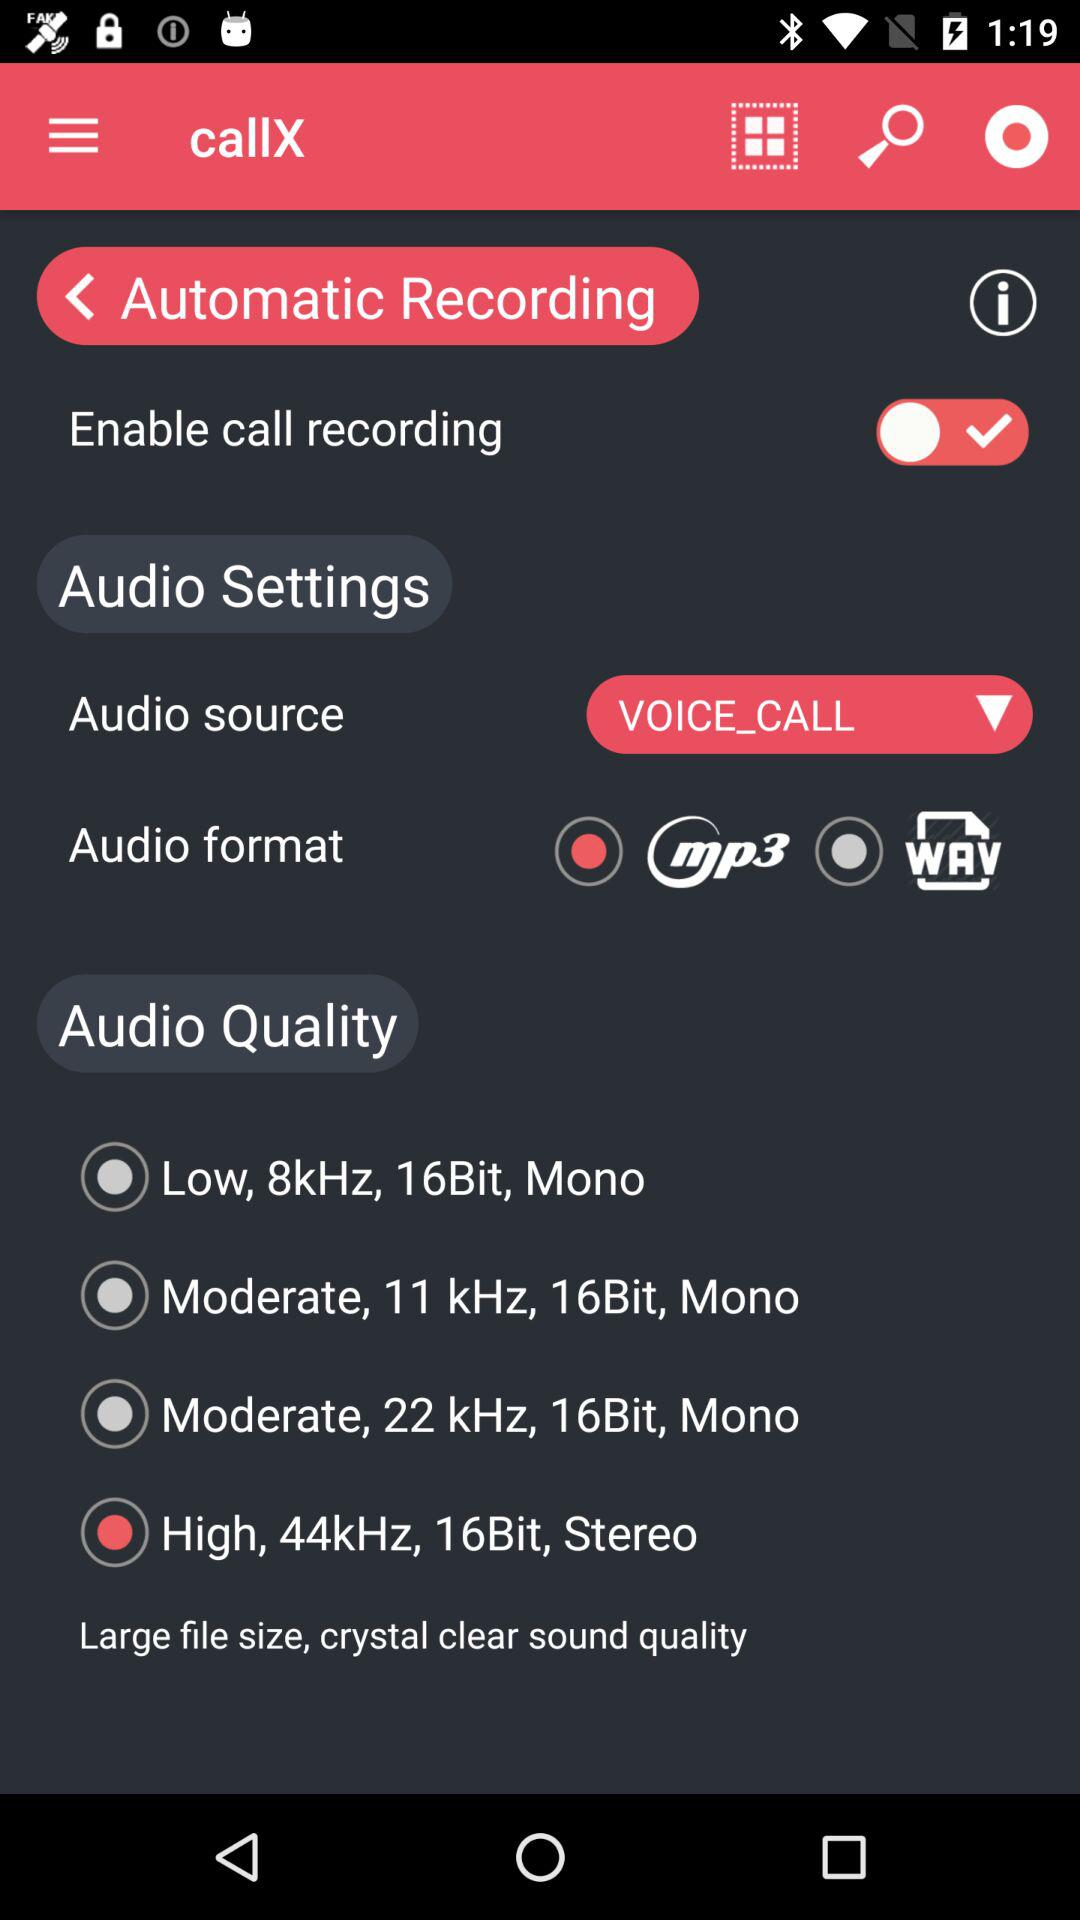What are the qualities of automatic recording?
When the provided information is insufficient, respond with <no answer>. <no answer> 